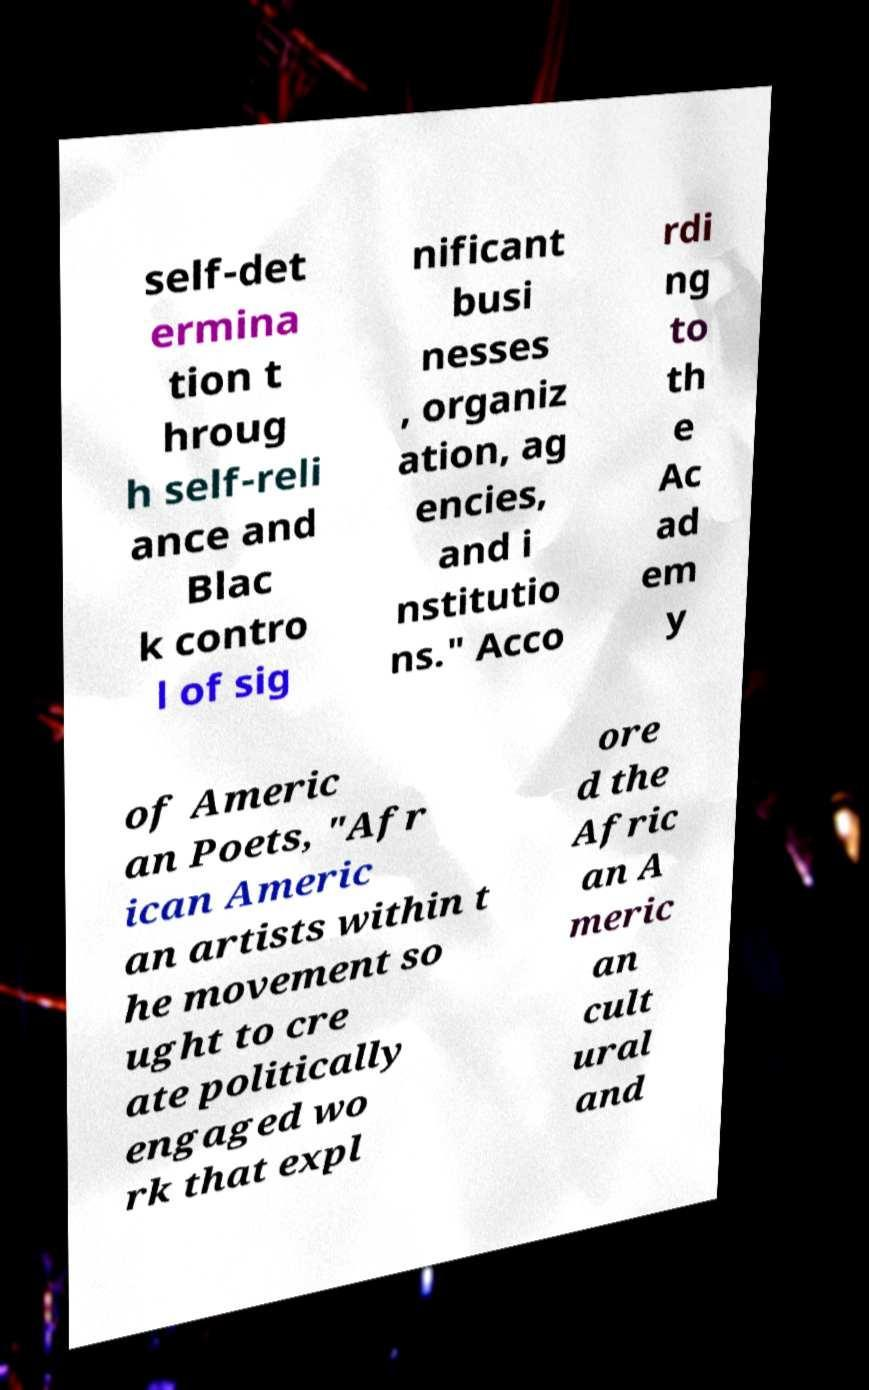What messages or text are displayed in this image? I need them in a readable, typed format. self-det ermina tion t hroug h self-reli ance and Blac k contro l of sig nificant busi nesses , organiz ation, ag encies, and i nstitutio ns." Acco rdi ng to th e Ac ad em y of Americ an Poets, "Afr ican Americ an artists within t he movement so ught to cre ate politically engaged wo rk that expl ore d the Afric an A meric an cult ural and 